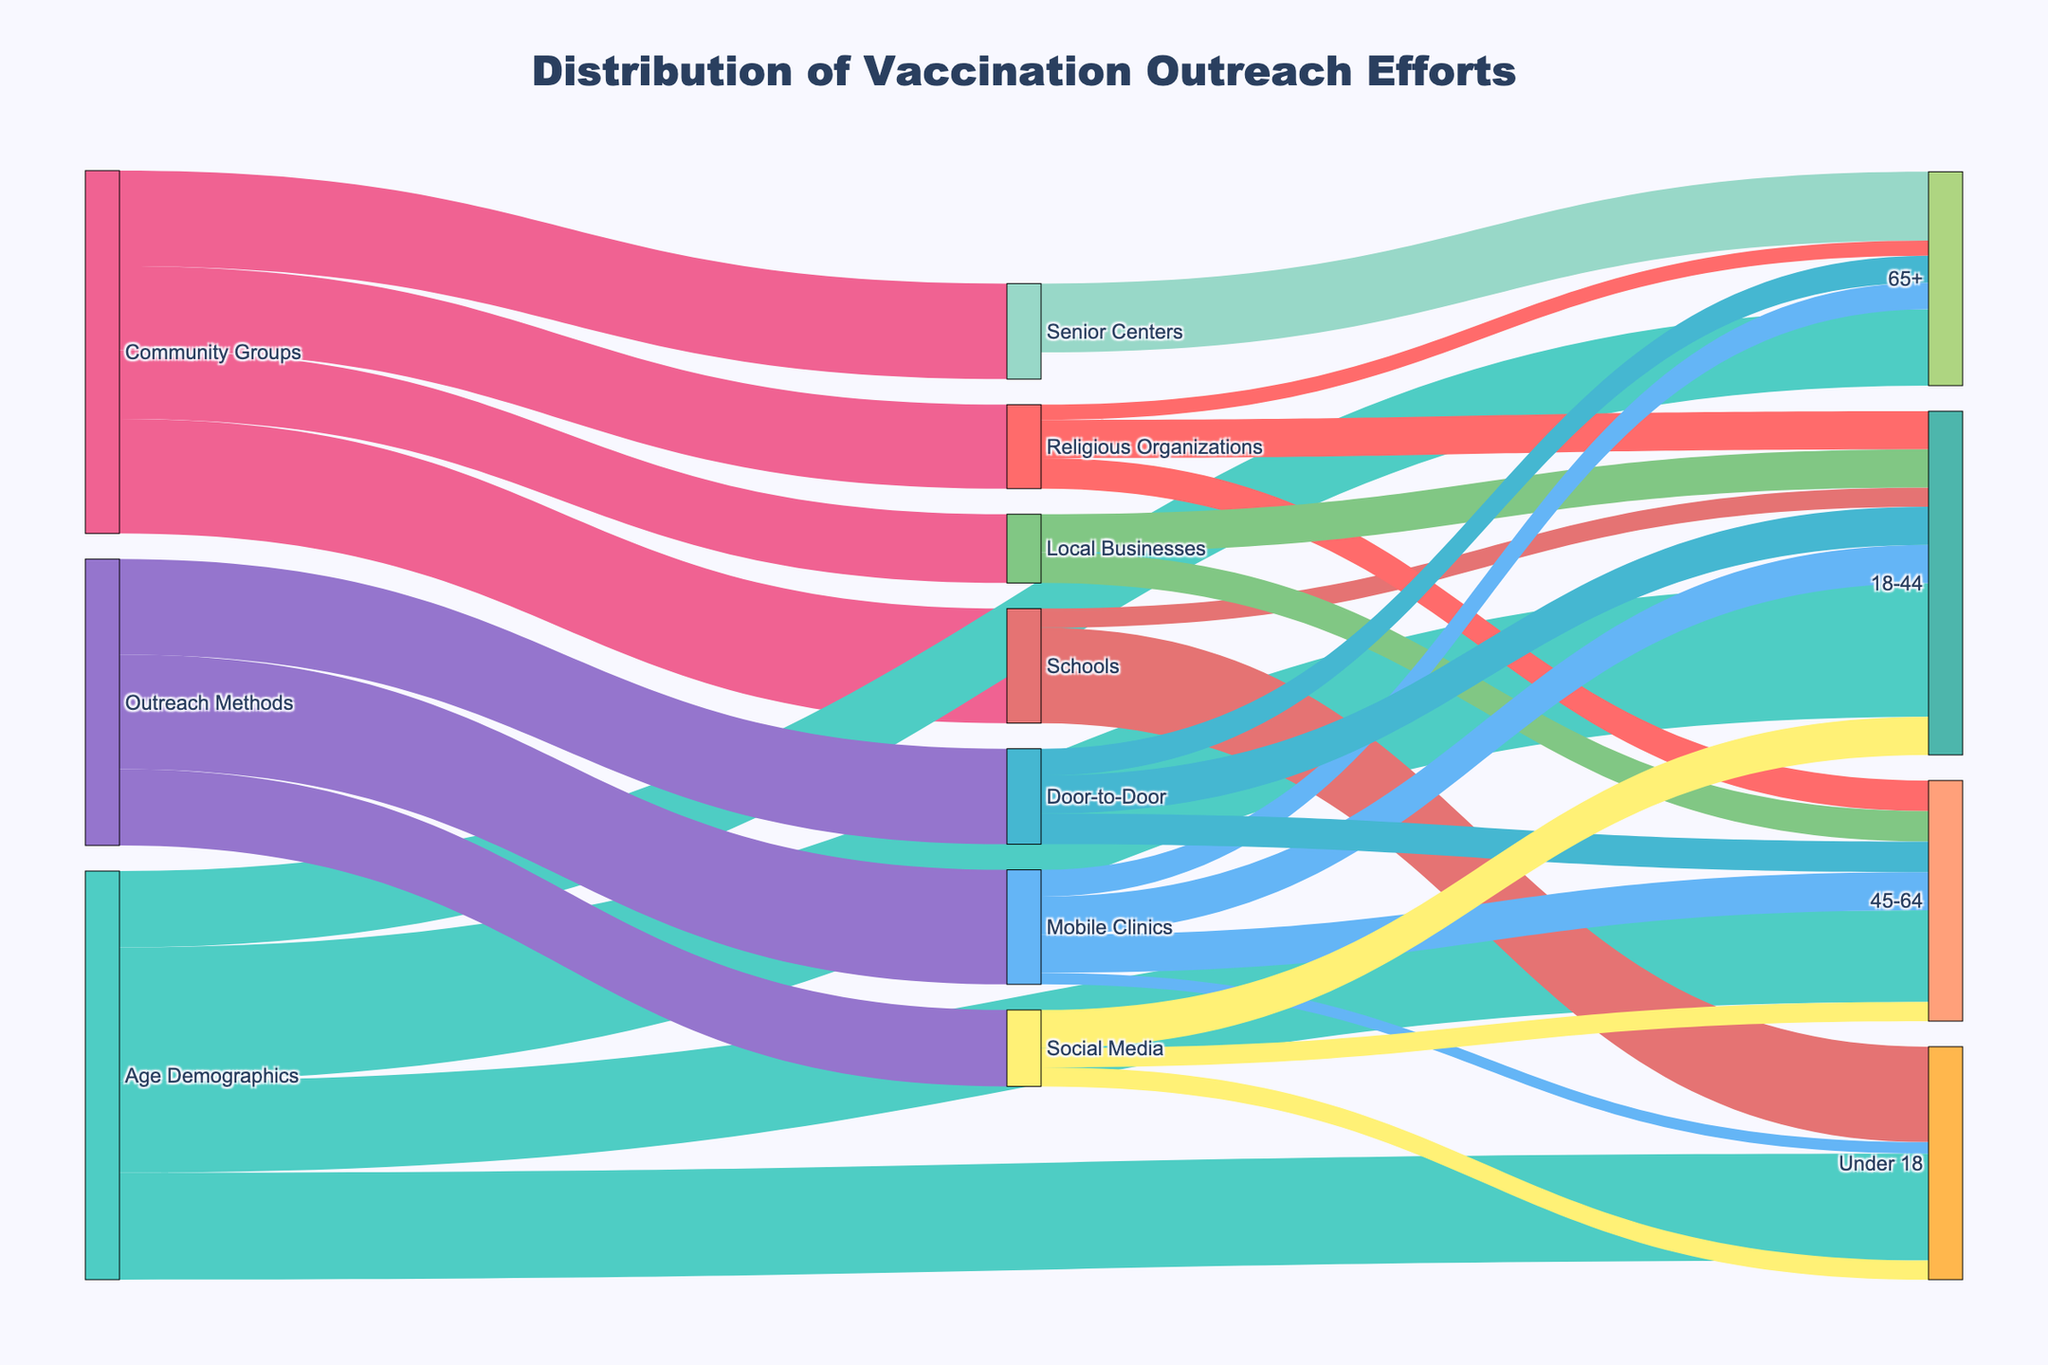Which community group reached the most people? To find the community group that reached the most people, look at the flows from "Community Groups". The sums are: Senior Centers (2500), Schools (3000), Religious Organizations (2200), and Local Businesses (1800). The highest is Schools with 3000.
Answer: Schools How many individuals aged 65+ were reached through Senior Centers? Check the link between "Senior Centers" and "65+"; it shows the number 1800.
Answer: 1800 Which outreach method reached the highest number of people in the 45-64 age category? Look at the flows from "Mobile Clinics", "Door-to-Door", and "Social Media" to "45-64". Mobile Clinics and Door-to-Door each reached 1000 people, which is the highest number.
Answer: Mobile Clinics and Door-to-Door What is the total number of people reached by the outreach methods combined? Sum the values of all links from "Outreach Methods": Mobile Clinics (3000), Door-to-Door (2500), Social Media (2000). The total is 7500.
Answer: 7500 Which age demographic is the least reached by all outreach methods combined? Sum the values going into each age demographic: Under 18 (300 + 500 = 800), 18-44 (1000 + 1000 + 1000 = 3000), 45-64 (1000 + 800 + 500 = 2300), 65+ (700 + 700 = 1400). 65+ is the least reached with 1400.
Answer: 65+ Through which channel did Schools reach the highest number of people? Check the links that originate from "Schools" and their corresponding numbers: Under 18 (2500), 18-44 (500). The highest is Under 18 with 2500.
Answer: Under 18 Which age demographic did the Religious Organizations reach most? Check the links from "Religious Organizations": 18-44 (1000), 45-64 (800), 65+ (400). The highest number is 18-44 with 1000.
Answer: 18-44 What is the difference between the number of people reached by Social Media and Door-to-Door in the 45-64 age group? Look at the links from "Social Media" to "45-64" (500) and "Door-to-Door" to "45-64" (800). The difference is 800 - 500 = 300.
Answer: 300 What proportion of the 18-44 age group was reached by Local Businesses compared to total outreach efforts for that demographic? Sum all links targeting "18-44": Schools (500), Religious Organizations (1000), Local Businesses (1000), Mobile Clinics (1000), Door-to-Door (1000), Social Media (1000). Total is 5500. Local Businesses reached 1000. The proportion is 1000/5500 = 0.18 or 18%.
Answer: 18% How many people did Religious Organizations and Local Businesses combined reach in the 45-64 age group? Look at the links from "Religious Organizations" to "45-64" (800) and "Local Businesses" to "45-64" (800). Combined, they reached 800 + 800 = 1600.
Answer: 1600 